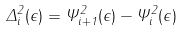<formula> <loc_0><loc_0><loc_500><loc_500>\Delta _ { i } ^ { 2 } ( \epsilon ) = \Psi _ { i + 1 } ^ { 2 } ( \epsilon ) - \Psi _ { i } ^ { 2 } ( \epsilon )</formula> 